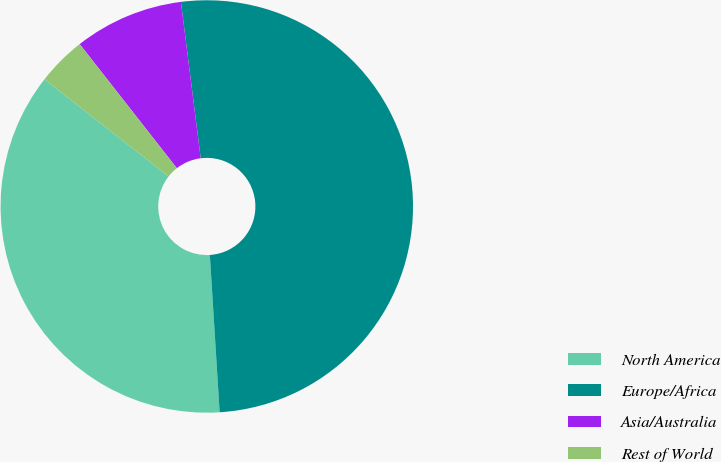Convert chart. <chart><loc_0><loc_0><loc_500><loc_500><pie_chart><fcel>North America<fcel>Europe/Africa<fcel>Asia/Australia<fcel>Rest of World<nl><fcel>36.57%<fcel>51.01%<fcel>8.57%<fcel>3.85%<nl></chart> 